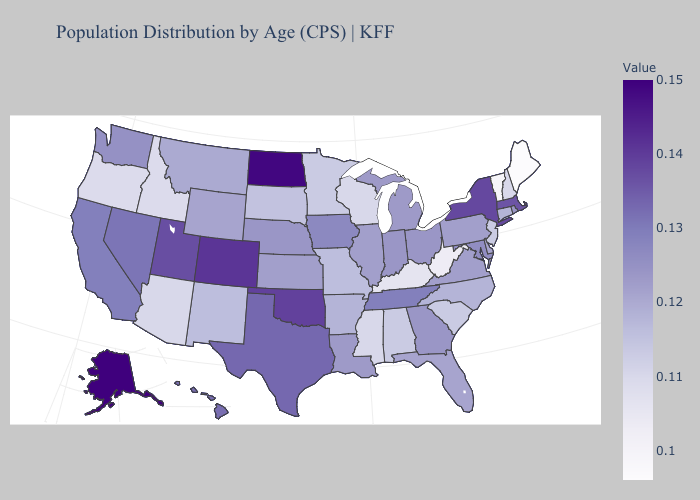Does Indiana have a lower value than Idaho?
Short answer required. No. Which states have the highest value in the USA?
Quick response, please. Alaska. Among the states that border Kansas , does Oklahoma have the highest value?
Write a very short answer. No. Does the map have missing data?
Be succinct. No. Which states have the highest value in the USA?
Be succinct. Alaska. 